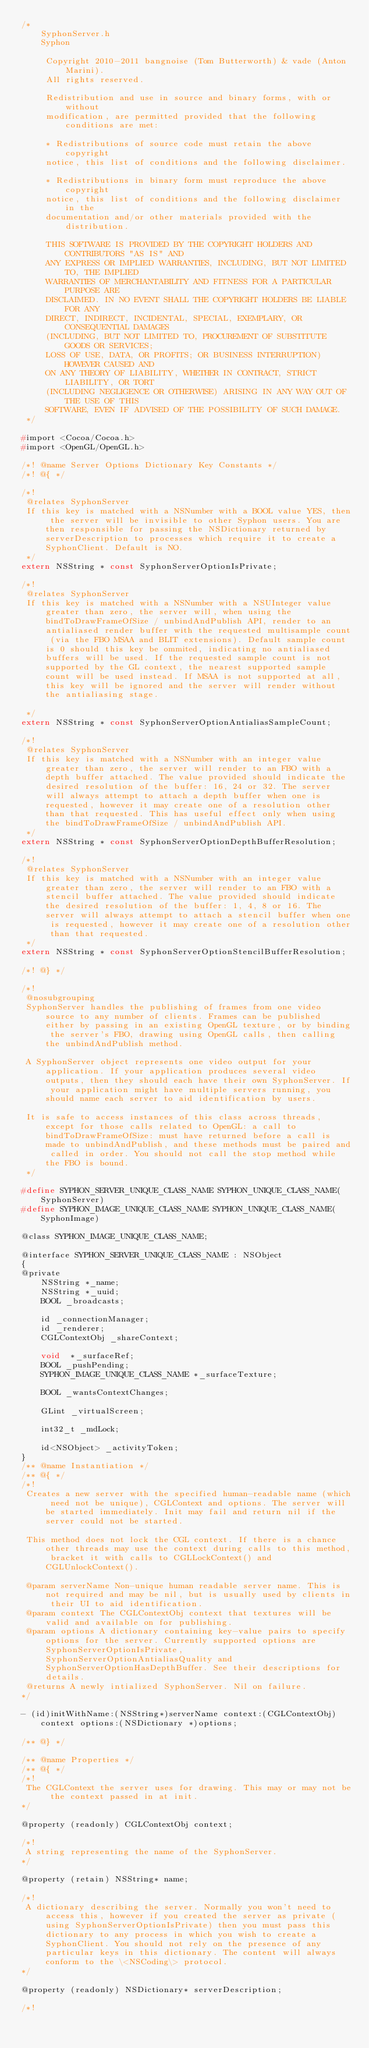<code> <loc_0><loc_0><loc_500><loc_500><_C_>/*
    SyphonServer.h
    Syphon

     Copyright 2010-2011 bangnoise (Tom Butterworth) & vade (Anton Marini).
     All rights reserved.
     
     Redistribution and use in source and binary forms, with or without
     modification, are permitted provided that the following conditions are met:
     
     * Redistributions of source code must retain the above copyright
     notice, this list of conditions and the following disclaimer.
     
     * Redistributions in binary form must reproduce the above copyright
     notice, this list of conditions and the following disclaimer in the
     documentation and/or other materials provided with the distribution.
     
     THIS SOFTWARE IS PROVIDED BY THE COPYRIGHT HOLDERS AND CONTRIBUTORS "AS IS" AND
     ANY EXPRESS OR IMPLIED WARRANTIES, INCLUDING, BUT NOT LIMITED TO, THE IMPLIED
     WARRANTIES OF MERCHANTABILITY AND FITNESS FOR A PARTICULAR PURPOSE ARE
     DISCLAIMED. IN NO EVENT SHALL THE COPYRIGHT HOLDERS BE LIABLE FOR ANY
     DIRECT, INDIRECT, INCIDENTAL, SPECIAL, EXEMPLARY, OR CONSEQUENTIAL DAMAGES
     (INCLUDING, BUT NOT LIMITED TO, PROCUREMENT OF SUBSTITUTE GOODS OR SERVICES;
     LOSS OF USE, DATA, OR PROFITS; OR BUSINESS INTERRUPTION) HOWEVER CAUSED AND
     ON ANY THEORY OF LIABILITY, WHETHER IN CONTRACT, STRICT LIABILITY, OR TORT
     (INCLUDING NEGLIGENCE OR OTHERWISE) ARISING IN ANY WAY OUT OF THE USE OF THIS
     SOFTWARE, EVEN IF ADVISED OF THE POSSIBILITY OF SUCH DAMAGE.
 */

#import <Cocoa/Cocoa.h>
#import <OpenGL/OpenGL.h>

/*! @name Server Options Dictionary Key Constants */
/*! @{ */

/*!
 @relates SyphonServer
 If this key is matched with a NSNumber with a BOOL value YES, then the server will be invisible to other Syphon users. You are then responsible for passing the NSDictionary returned by serverDescription to processes which require it to create a SyphonClient. Default is NO.
 */
extern NSString * const SyphonServerOptionIsPrivate;

/*!
 @relates SyphonServer
 If this key is matched with a NSNumber with a NSUInteger value greater than zero, the server will, when using the bindToDrawFrameOfSize / unbindAndPublish API, render to an antialiased render buffer with the requested multisample count (via the FBO MSAA and BLIT extensions). Default sample count is 0 should this key be ommited, indicating no antialiased buffers will be used. If the requested sample count is not supported by the GL context, the nearest supported sample count will be used instead. If MSAA is not supported at all, this key will be ignored and the server will render without the antialiasing stage.
 
 */
extern NSString * const SyphonServerOptionAntialiasSampleCount;

/*!
 @relates SyphonServer
 If this key is matched with a NSNumber with an integer value greater than zero, the server will render to an FBO with a depth buffer attached. The value provided should indicate the desired resolution of the buffer: 16, 24 or 32. The server will always attempt to attach a depth buffer when one is requested, however it may create one of a resolution other than that requested. This has useful effect only when using the bindToDrawFrameOfSize / unbindAndPublish API.
 */
extern NSString * const SyphonServerOptionDepthBufferResolution;

/*!
 @relates SyphonServer
 If this key is matched with a NSNumber with an integer value greater than zero, the server will render to an FBO with a stencil buffer attached. The value provided should indicate the desired resolution of the buffer: 1, 4, 8 or 16. The server will always attempt to attach a stencil buffer when one is requested, however it may create one of a resolution other than that requested.
 */
extern NSString * const SyphonServerOptionStencilBufferResolution;

/*! @} */

/*!
 @nosubgrouping
 SyphonServer handles the publishing of frames from one video source to any number of clients. Frames can be published either by passing in an existing OpenGL texture, or by binding the server's FBO, drawing using OpenGL calls, then calling the unbindAndPublish method.
 
 A SyphonServer object represents one video output for your application. If your application produces several video outputs, then they should each have their own SyphonServer. If your application might have multiple servers running, you should name each server to aid identification by users.
 
 It is safe to access instances of this class across threads, except for those calls related to OpenGL: a call to bindToDrawFrameOfSize: must have returned before a call is made to unbindAndPublish, and these methods must be paired and called in order. You should not call the stop method while the FBO is bound.
 */

#define SYPHON_SERVER_UNIQUE_CLASS_NAME SYPHON_UNIQUE_CLASS_NAME(SyphonServer)
#define SYPHON_IMAGE_UNIQUE_CLASS_NAME SYPHON_UNIQUE_CLASS_NAME(SyphonImage)

@class SYPHON_IMAGE_UNIQUE_CLASS_NAME;

@interface SYPHON_SERVER_UNIQUE_CLASS_NAME : NSObject
{
@private
	NSString *_name;
	NSString *_uuid;
	BOOL _broadcasts;
	
	id _connectionManager;
    id _renderer;
    CGLContextObj _shareContext;
	
	void  *_surfaceRef;
	BOOL _pushPending;
	SYPHON_IMAGE_UNIQUE_CLASS_NAME *_surfaceTexture;
	
    BOOL _wantsContextChanges;
    
    GLint _virtualScreen;
    
	int32_t _mdLock;

    id<NSObject> _activityToken;
}
/** @name Instantiation */
/** @{ */
/*!
 Creates a new server with the specified human-readable name (which need not be unique), CGLContext and options. The server will be started immediately. Init may fail and return nil if the server could not be started.
 
 This method does not lock the CGL context. If there is a chance other threads may use the context during calls to this method, bracket it with calls to CGLLockContext() and CGLUnlockContext().

 @param serverName Non-unique human readable server name. This is not required and may be nil, but is usually used by clients in their UI to aid identification.
 @param context The CGLContextObj context that textures will be valid and available on for publishing.
 @param options A dictionary containing key-value pairs to specify options for the server. Currently supported options are SyphonServerOptionIsPrivate, SyphonServerOptionAntialiasQuality and SyphonServerOptionHasDepthBuffer. See their descriptions for details.
 @returns A newly intialized SyphonServer. Nil on failure.
*/

- (id)initWithName:(NSString*)serverName context:(CGLContextObj)context options:(NSDictionary *)options;

/** @} */

/** @name Properties */
/** @{ */
/*!
 The CGLContext the server uses for drawing. This may or may not be the context passed in at init.
*/

@property (readonly) CGLContextObj context;

/*! 
 A string representing the name of the SyphonServer.
*/ 

@property (retain) NSString* name;

/*! 
 A dictionary describing the server. Normally you won't need to access this, however if you created the server as private (using SyphonServerOptionIsPrivate) then you must pass this dictionary to any process in which you wish to create a SyphonClient. You should not rely on the presence of any particular keys in this dictionary. The content will always conform to the \<NSCoding\> protocol.
*/

@property (readonly) NSDictionary* serverDescription;

/*! </code> 